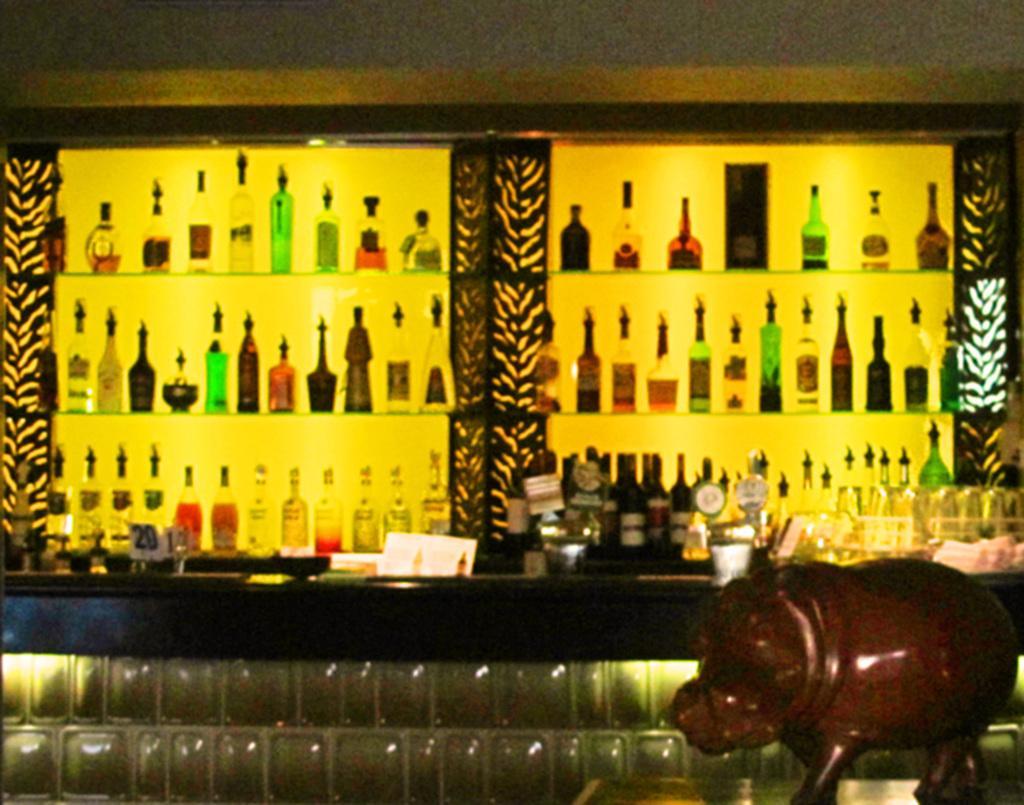In one or two sentences, can you explain what this image depicts? In this image we can see a group of wine bottles in the rack, and here are some objects. 